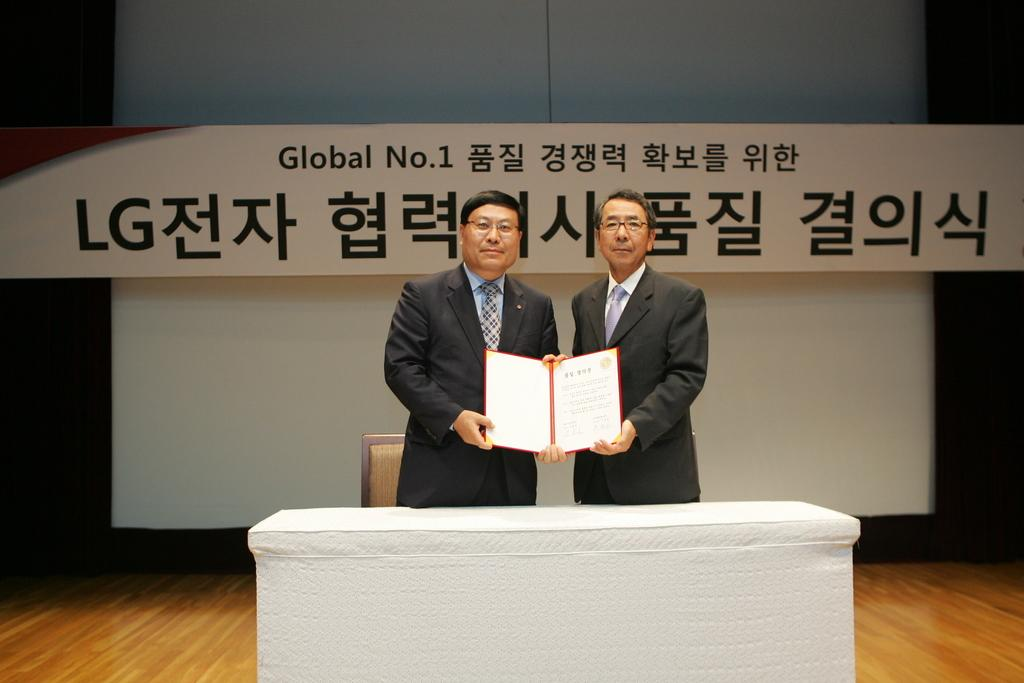How many people are in the image? There are two men in the image. What are the men doing in the image? The men are standing at a table. What are the men holding in their hands? The men are holding an object in their hands. Can you describe the background of the image? There is a chair, a floor, texts written on a board, and an object visible in the background. What type of verse is being recited by the lawyer in the image? There is no lawyer or verse present in the image. What is the men's opinion on hate in the image? There is no indication of the men's opinions or feelings about hate in the image. 